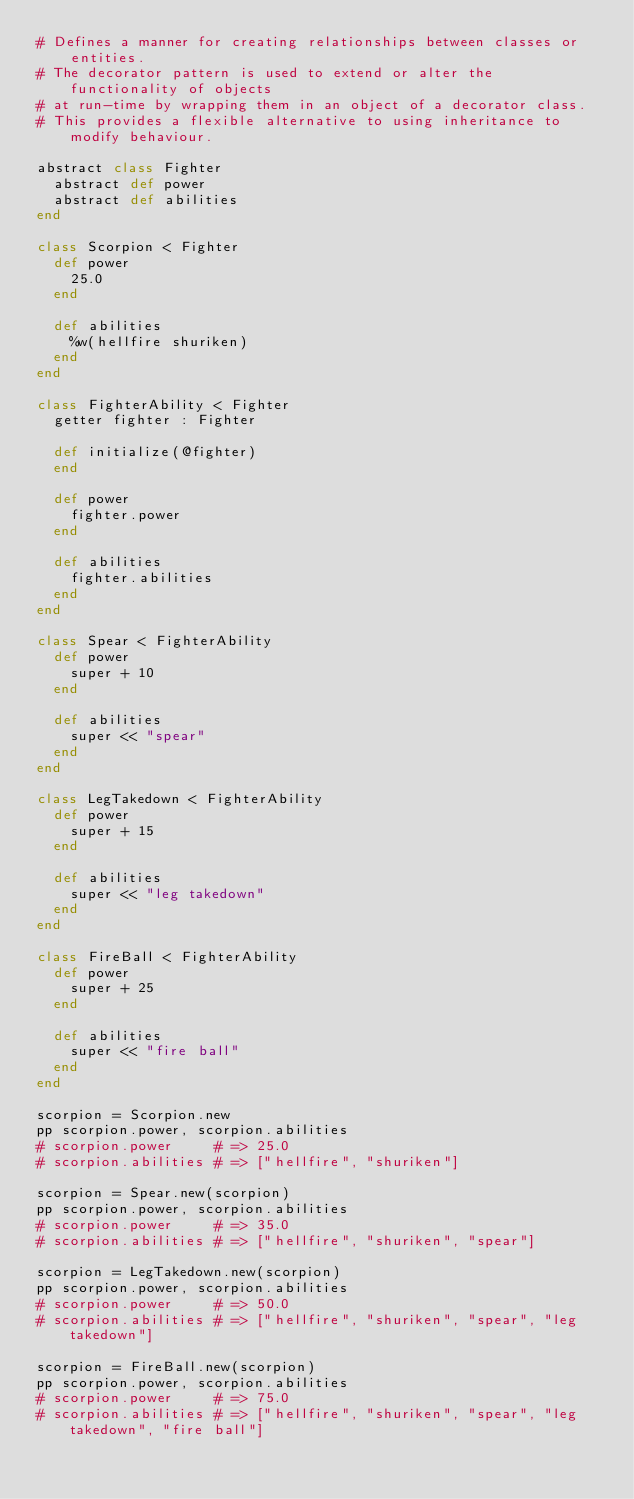Convert code to text. <code><loc_0><loc_0><loc_500><loc_500><_Crystal_># Defines a manner for creating relationships between classes or entities.
# The decorator pattern is used to extend or alter the functionality of objects
# at run-time by wrapping them in an object of a decorator class.
# This provides a flexible alternative to using inheritance to modify behaviour.

abstract class Fighter
  abstract def power
  abstract def abilities
end

class Scorpion < Fighter
  def power
    25.0
  end

  def abilities
    %w(hellfire shuriken)
  end
end

class FighterAbility < Fighter
  getter fighter : Fighter

  def initialize(@fighter)
  end

  def power
    fighter.power
  end

  def abilities
    fighter.abilities
  end
end

class Spear < FighterAbility
  def power
    super + 10
  end

  def abilities
    super << "spear"
  end
end

class LegTakedown < FighterAbility
  def power
    super + 15
  end

  def abilities
    super << "leg takedown"
  end
end

class FireBall < FighterAbility
  def power
    super + 25
  end

  def abilities
    super << "fire ball"
  end
end

scorpion = Scorpion.new
pp scorpion.power, scorpion.abilities
# scorpion.power     # => 25.0
# scorpion.abilities # => ["hellfire", "shuriken"]

scorpion = Spear.new(scorpion)
pp scorpion.power, scorpion.abilities
# scorpion.power     # => 35.0
# scorpion.abilities # => ["hellfire", "shuriken", "spear"]

scorpion = LegTakedown.new(scorpion)
pp scorpion.power, scorpion.abilities
# scorpion.power     # => 50.0
# scorpion.abilities # => ["hellfire", "shuriken", "spear", "leg takedown"]

scorpion = FireBall.new(scorpion)
pp scorpion.power, scorpion.abilities
# scorpion.power     # => 75.0
# scorpion.abilities # => ["hellfire", "shuriken", "spear", "leg takedown", "fire ball"]
</code> 